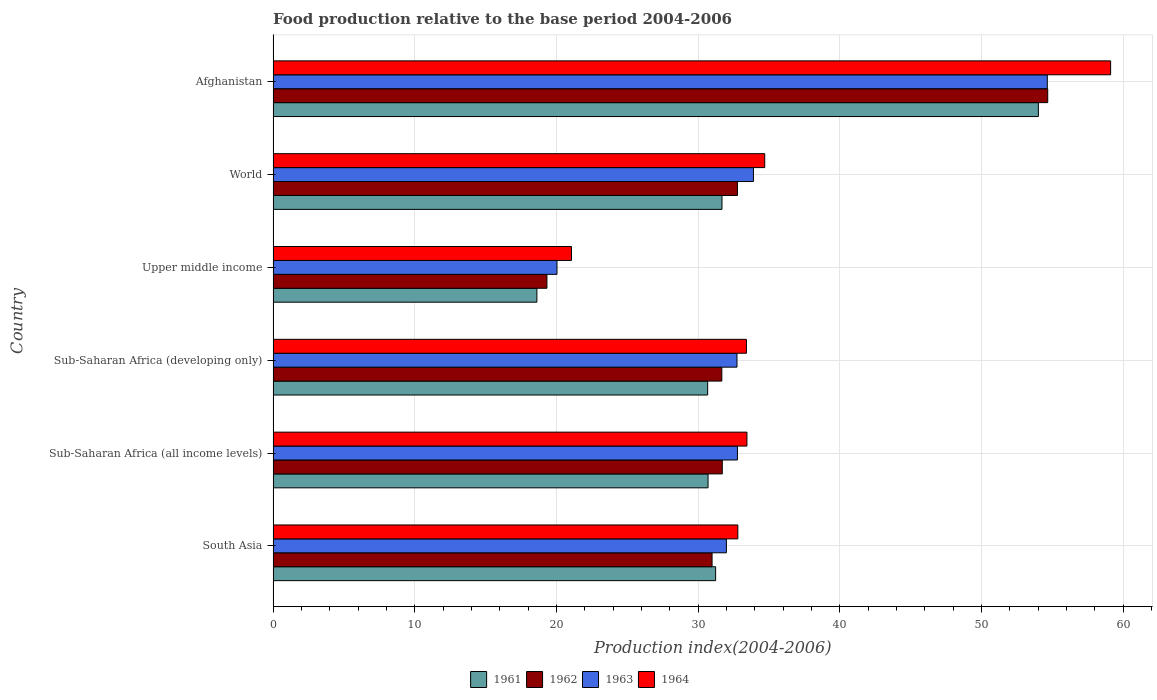How many bars are there on the 5th tick from the bottom?
Provide a short and direct response. 4. What is the label of the 1st group of bars from the top?
Provide a short and direct response. Afghanistan. In how many cases, is the number of bars for a given country not equal to the number of legend labels?
Your response must be concise. 0. What is the food production index in 1961 in Upper middle income?
Offer a terse response. 18.62. Across all countries, what is the maximum food production index in 1964?
Give a very brief answer. 59.12. Across all countries, what is the minimum food production index in 1961?
Provide a short and direct response. 18.62. In which country was the food production index in 1963 maximum?
Your answer should be very brief. Afghanistan. In which country was the food production index in 1961 minimum?
Make the answer very short. Upper middle income. What is the total food production index in 1964 in the graph?
Give a very brief answer. 214.55. What is the difference between the food production index in 1964 in Afghanistan and that in Sub-Saharan Africa (all income levels)?
Your response must be concise. 25.67. What is the difference between the food production index in 1962 in Sub-Saharan Africa (developing only) and the food production index in 1963 in Afghanistan?
Your answer should be compact. -22.97. What is the average food production index in 1964 per country?
Ensure brevity in your answer.  35.76. What is the difference between the food production index in 1963 and food production index in 1962 in Upper middle income?
Your answer should be compact. 0.71. What is the ratio of the food production index in 1963 in South Asia to that in Sub-Saharan Africa (all income levels)?
Your answer should be very brief. 0.98. Is the food production index in 1961 in Afghanistan less than that in Upper middle income?
Your answer should be very brief. No. What is the difference between the highest and the second highest food production index in 1963?
Provide a short and direct response. 20.74. What is the difference between the highest and the lowest food production index in 1962?
Keep it short and to the point. 35.35. Is it the case that in every country, the sum of the food production index in 1962 and food production index in 1961 is greater than the sum of food production index in 1964 and food production index in 1963?
Make the answer very short. No. What does the 1st bar from the top in World represents?
Make the answer very short. 1964. Is it the case that in every country, the sum of the food production index in 1963 and food production index in 1964 is greater than the food production index in 1961?
Offer a terse response. Yes. Are all the bars in the graph horizontal?
Your response must be concise. Yes. How many countries are there in the graph?
Ensure brevity in your answer.  6. What is the difference between two consecutive major ticks on the X-axis?
Ensure brevity in your answer.  10. Are the values on the major ticks of X-axis written in scientific E-notation?
Your response must be concise. No. Does the graph contain any zero values?
Ensure brevity in your answer.  No. Does the graph contain grids?
Ensure brevity in your answer.  Yes. Where does the legend appear in the graph?
Provide a short and direct response. Bottom center. What is the title of the graph?
Offer a very short reply. Food production relative to the base period 2004-2006. What is the label or title of the X-axis?
Make the answer very short. Production index(2004-2006). What is the Production index(2004-2006) in 1961 in South Asia?
Provide a succinct answer. 31.24. What is the Production index(2004-2006) of 1962 in South Asia?
Give a very brief answer. 30.99. What is the Production index(2004-2006) of 1963 in South Asia?
Ensure brevity in your answer.  32. What is the Production index(2004-2006) in 1964 in South Asia?
Give a very brief answer. 32.8. What is the Production index(2004-2006) in 1961 in Sub-Saharan Africa (all income levels)?
Offer a very short reply. 30.7. What is the Production index(2004-2006) in 1962 in Sub-Saharan Africa (all income levels)?
Make the answer very short. 31.71. What is the Production index(2004-2006) in 1963 in Sub-Saharan Africa (all income levels)?
Provide a succinct answer. 32.78. What is the Production index(2004-2006) of 1964 in Sub-Saharan Africa (all income levels)?
Keep it short and to the point. 33.45. What is the Production index(2004-2006) in 1961 in Sub-Saharan Africa (developing only)?
Provide a succinct answer. 30.68. What is the Production index(2004-2006) of 1962 in Sub-Saharan Africa (developing only)?
Ensure brevity in your answer.  31.68. What is the Production index(2004-2006) of 1963 in Sub-Saharan Africa (developing only)?
Provide a succinct answer. 32.75. What is the Production index(2004-2006) of 1964 in Sub-Saharan Africa (developing only)?
Keep it short and to the point. 33.41. What is the Production index(2004-2006) in 1961 in Upper middle income?
Offer a very short reply. 18.62. What is the Production index(2004-2006) in 1962 in Upper middle income?
Provide a short and direct response. 19.33. What is the Production index(2004-2006) of 1963 in Upper middle income?
Your response must be concise. 20.04. What is the Production index(2004-2006) of 1964 in Upper middle income?
Ensure brevity in your answer.  21.06. What is the Production index(2004-2006) in 1961 in World?
Your response must be concise. 31.69. What is the Production index(2004-2006) in 1962 in World?
Offer a terse response. 32.78. What is the Production index(2004-2006) of 1963 in World?
Provide a short and direct response. 33.91. What is the Production index(2004-2006) in 1964 in World?
Your answer should be very brief. 34.7. What is the Production index(2004-2006) in 1961 in Afghanistan?
Offer a very short reply. 54.02. What is the Production index(2004-2006) in 1962 in Afghanistan?
Make the answer very short. 54.68. What is the Production index(2004-2006) of 1963 in Afghanistan?
Ensure brevity in your answer.  54.65. What is the Production index(2004-2006) of 1964 in Afghanistan?
Give a very brief answer. 59.12. Across all countries, what is the maximum Production index(2004-2006) of 1961?
Your answer should be compact. 54.02. Across all countries, what is the maximum Production index(2004-2006) in 1962?
Your response must be concise. 54.68. Across all countries, what is the maximum Production index(2004-2006) in 1963?
Ensure brevity in your answer.  54.65. Across all countries, what is the maximum Production index(2004-2006) of 1964?
Give a very brief answer. 59.12. Across all countries, what is the minimum Production index(2004-2006) in 1961?
Give a very brief answer. 18.62. Across all countries, what is the minimum Production index(2004-2006) of 1962?
Ensure brevity in your answer.  19.33. Across all countries, what is the minimum Production index(2004-2006) in 1963?
Give a very brief answer. 20.04. Across all countries, what is the minimum Production index(2004-2006) in 1964?
Offer a terse response. 21.06. What is the total Production index(2004-2006) in 1961 in the graph?
Ensure brevity in your answer.  196.94. What is the total Production index(2004-2006) in 1962 in the graph?
Your response must be concise. 201.15. What is the total Production index(2004-2006) in 1963 in the graph?
Provide a short and direct response. 206.11. What is the total Production index(2004-2006) in 1964 in the graph?
Provide a short and direct response. 214.55. What is the difference between the Production index(2004-2006) in 1961 in South Asia and that in Sub-Saharan Africa (all income levels)?
Offer a terse response. 0.54. What is the difference between the Production index(2004-2006) of 1962 in South Asia and that in Sub-Saharan Africa (all income levels)?
Your answer should be compact. -0.72. What is the difference between the Production index(2004-2006) in 1963 in South Asia and that in Sub-Saharan Africa (all income levels)?
Provide a succinct answer. -0.78. What is the difference between the Production index(2004-2006) of 1964 in South Asia and that in Sub-Saharan Africa (all income levels)?
Offer a very short reply. -0.64. What is the difference between the Production index(2004-2006) of 1961 in South Asia and that in Sub-Saharan Africa (developing only)?
Provide a succinct answer. 0.56. What is the difference between the Production index(2004-2006) of 1962 in South Asia and that in Sub-Saharan Africa (developing only)?
Your response must be concise. -0.69. What is the difference between the Production index(2004-2006) in 1963 in South Asia and that in Sub-Saharan Africa (developing only)?
Ensure brevity in your answer.  -0.75. What is the difference between the Production index(2004-2006) of 1964 in South Asia and that in Sub-Saharan Africa (developing only)?
Your response must be concise. -0.61. What is the difference between the Production index(2004-2006) of 1961 in South Asia and that in Upper middle income?
Make the answer very short. 12.62. What is the difference between the Production index(2004-2006) of 1962 in South Asia and that in Upper middle income?
Your answer should be compact. 11.66. What is the difference between the Production index(2004-2006) in 1963 in South Asia and that in Upper middle income?
Your answer should be very brief. 11.96. What is the difference between the Production index(2004-2006) in 1964 in South Asia and that in Upper middle income?
Offer a very short reply. 11.74. What is the difference between the Production index(2004-2006) in 1961 in South Asia and that in World?
Give a very brief answer. -0.45. What is the difference between the Production index(2004-2006) in 1962 in South Asia and that in World?
Make the answer very short. -1.79. What is the difference between the Production index(2004-2006) of 1963 in South Asia and that in World?
Keep it short and to the point. -1.91. What is the difference between the Production index(2004-2006) of 1964 in South Asia and that in World?
Your response must be concise. -1.9. What is the difference between the Production index(2004-2006) of 1961 in South Asia and that in Afghanistan?
Your response must be concise. -22.78. What is the difference between the Production index(2004-2006) in 1962 in South Asia and that in Afghanistan?
Your response must be concise. -23.69. What is the difference between the Production index(2004-2006) of 1963 in South Asia and that in Afghanistan?
Offer a very short reply. -22.65. What is the difference between the Production index(2004-2006) of 1964 in South Asia and that in Afghanistan?
Offer a very short reply. -26.32. What is the difference between the Production index(2004-2006) of 1961 in Sub-Saharan Africa (all income levels) and that in Sub-Saharan Africa (developing only)?
Your answer should be compact. 0.03. What is the difference between the Production index(2004-2006) of 1962 in Sub-Saharan Africa (all income levels) and that in Sub-Saharan Africa (developing only)?
Offer a terse response. 0.03. What is the difference between the Production index(2004-2006) of 1963 in Sub-Saharan Africa (all income levels) and that in Sub-Saharan Africa (developing only)?
Keep it short and to the point. 0.03. What is the difference between the Production index(2004-2006) of 1964 in Sub-Saharan Africa (all income levels) and that in Sub-Saharan Africa (developing only)?
Your response must be concise. 0.04. What is the difference between the Production index(2004-2006) of 1961 in Sub-Saharan Africa (all income levels) and that in Upper middle income?
Offer a very short reply. 12.08. What is the difference between the Production index(2004-2006) in 1962 in Sub-Saharan Africa (all income levels) and that in Upper middle income?
Provide a succinct answer. 12.38. What is the difference between the Production index(2004-2006) in 1963 in Sub-Saharan Africa (all income levels) and that in Upper middle income?
Your response must be concise. 12.74. What is the difference between the Production index(2004-2006) in 1964 in Sub-Saharan Africa (all income levels) and that in Upper middle income?
Your response must be concise. 12.38. What is the difference between the Production index(2004-2006) in 1961 in Sub-Saharan Africa (all income levels) and that in World?
Give a very brief answer. -0.98. What is the difference between the Production index(2004-2006) of 1962 in Sub-Saharan Africa (all income levels) and that in World?
Offer a very short reply. -1.07. What is the difference between the Production index(2004-2006) in 1963 in Sub-Saharan Africa (all income levels) and that in World?
Ensure brevity in your answer.  -1.13. What is the difference between the Production index(2004-2006) of 1964 in Sub-Saharan Africa (all income levels) and that in World?
Your answer should be compact. -1.26. What is the difference between the Production index(2004-2006) of 1961 in Sub-Saharan Africa (all income levels) and that in Afghanistan?
Offer a terse response. -23.32. What is the difference between the Production index(2004-2006) of 1962 in Sub-Saharan Africa (all income levels) and that in Afghanistan?
Offer a terse response. -22.97. What is the difference between the Production index(2004-2006) in 1963 in Sub-Saharan Africa (all income levels) and that in Afghanistan?
Ensure brevity in your answer.  -21.87. What is the difference between the Production index(2004-2006) in 1964 in Sub-Saharan Africa (all income levels) and that in Afghanistan?
Offer a very short reply. -25.67. What is the difference between the Production index(2004-2006) in 1961 in Sub-Saharan Africa (developing only) and that in Upper middle income?
Give a very brief answer. 12.06. What is the difference between the Production index(2004-2006) in 1962 in Sub-Saharan Africa (developing only) and that in Upper middle income?
Make the answer very short. 12.35. What is the difference between the Production index(2004-2006) in 1963 in Sub-Saharan Africa (developing only) and that in Upper middle income?
Keep it short and to the point. 12.71. What is the difference between the Production index(2004-2006) in 1964 in Sub-Saharan Africa (developing only) and that in Upper middle income?
Offer a very short reply. 12.35. What is the difference between the Production index(2004-2006) in 1961 in Sub-Saharan Africa (developing only) and that in World?
Your response must be concise. -1.01. What is the difference between the Production index(2004-2006) of 1962 in Sub-Saharan Africa (developing only) and that in World?
Your response must be concise. -1.1. What is the difference between the Production index(2004-2006) of 1963 in Sub-Saharan Africa (developing only) and that in World?
Ensure brevity in your answer.  -1.16. What is the difference between the Production index(2004-2006) of 1964 in Sub-Saharan Africa (developing only) and that in World?
Offer a terse response. -1.29. What is the difference between the Production index(2004-2006) of 1961 in Sub-Saharan Africa (developing only) and that in Afghanistan?
Offer a very short reply. -23.34. What is the difference between the Production index(2004-2006) in 1962 in Sub-Saharan Africa (developing only) and that in Afghanistan?
Make the answer very short. -23. What is the difference between the Production index(2004-2006) of 1963 in Sub-Saharan Africa (developing only) and that in Afghanistan?
Make the answer very short. -21.91. What is the difference between the Production index(2004-2006) in 1964 in Sub-Saharan Africa (developing only) and that in Afghanistan?
Provide a succinct answer. -25.71. What is the difference between the Production index(2004-2006) in 1961 in Upper middle income and that in World?
Offer a very short reply. -13.07. What is the difference between the Production index(2004-2006) in 1962 in Upper middle income and that in World?
Provide a succinct answer. -13.45. What is the difference between the Production index(2004-2006) in 1963 in Upper middle income and that in World?
Offer a terse response. -13.87. What is the difference between the Production index(2004-2006) in 1964 in Upper middle income and that in World?
Your answer should be compact. -13.64. What is the difference between the Production index(2004-2006) in 1961 in Upper middle income and that in Afghanistan?
Offer a very short reply. -35.4. What is the difference between the Production index(2004-2006) in 1962 in Upper middle income and that in Afghanistan?
Offer a terse response. -35.35. What is the difference between the Production index(2004-2006) of 1963 in Upper middle income and that in Afghanistan?
Provide a short and direct response. -34.61. What is the difference between the Production index(2004-2006) in 1964 in Upper middle income and that in Afghanistan?
Keep it short and to the point. -38.06. What is the difference between the Production index(2004-2006) of 1961 in World and that in Afghanistan?
Offer a very short reply. -22.33. What is the difference between the Production index(2004-2006) in 1962 in World and that in Afghanistan?
Give a very brief answer. -21.9. What is the difference between the Production index(2004-2006) of 1963 in World and that in Afghanistan?
Offer a very short reply. -20.74. What is the difference between the Production index(2004-2006) in 1964 in World and that in Afghanistan?
Provide a short and direct response. -24.42. What is the difference between the Production index(2004-2006) in 1961 in South Asia and the Production index(2004-2006) in 1962 in Sub-Saharan Africa (all income levels)?
Offer a terse response. -0.47. What is the difference between the Production index(2004-2006) in 1961 in South Asia and the Production index(2004-2006) in 1963 in Sub-Saharan Africa (all income levels)?
Your answer should be compact. -1.54. What is the difference between the Production index(2004-2006) of 1961 in South Asia and the Production index(2004-2006) of 1964 in Sub-Saharan Africa (all income levels)?
Make the answer very short. -2.21. What is the difference between the Production index(2004-2006) in 1962 in South Asia and the Production index(2004-2006) in 1963 in Sub-Saharan Africa (all income levels)?
Provide a short and direct response. -1.79. What is the difference between the Production index(2004-2006) in 1962 in South Asia and the Production index(2004-2006) in 1964 in Sub-Saharan Africa (all income levels)?
Keep it short and to the point. -2.46. What is the difference between the Production index(2004-2006) of 1963 in South Asia and the Production index(2004-2006) of 1964 in Sub-Saharan Africa (all income levels)?
Give a very brief answer. -1.45. What is the difference between the Production index(2004-2006) of 1961 in South Asia and the Production index(2004-2006) of 1962 in Sub-Saharan Africa (developing only)?
Provide a short and direct response. -0.44. What is the difference between the Production index(2004-2006) of 1961 in South Asia and the Production index(2004-2006) of 1963 in Sub-Saharan Africa (developing only)?
Make the answer very short. -1.51. What is the difference between the Production index(2004-2006) of 1961 in South Asia and the Production index(2004-2006) of 1964 in Sub-Saharan Africa (developing only)?
Provide a succinct answer. -2.17. What is the difference between the Production index(2004-2006) of 1962 in South Asia and the Production index(2004-2006) of 1963 in Sub-Saharan Africa (developing only)?
Offer a very short reply. -1.76. What is the difference between the Production index(2004-2006) in 1962 in South Asia and the Production index(2004-2006) in 1964 in Sub-Saharan Africa (developing only)?
Make the answer very short. -2.43. What is the difference between the Production index(2004-2006) in 1963 in South Asia and the Production index(2004-2006) in 1964 in Sub-Saharan Africa (developing only)?
Provide a succinct answer. -1.42. What is the difference between the Production index(2004-2006) in 1961 in South Asia and the Production index(2004-2006) in 1962 in Upper middle income?
Offer a very short reply. 11.91. What is the difference between the Production index(2004-2006) of 1961 in South Asia and the Production index(2004-2006) of 1963 in Upper middle income?
Make the answer very short. 11.2. What is the difference between the Production index(2004-2006) in 1961 in South Asia and the Production index(2004-2006) in 1964 in Upper middle income?
Offer a terse response. 10.18. What is the difference between the Production index(2004-2006) of 1962 in South Asia and the Production index(2004-2006) of 1963 in Upper middle income?
Your answer should be compact. 10.95. What is the difference between the Production index(2004-2006) in 1962 in South Asia and the Production index(2004-2006) in 1964 in Upper middle income?
Your response must be concise. 9.92. What is the difference between the Production index(2004-2006) of 1963 in South Asia and the Production index(2004-2006) of 1964 in Upper middle income?
Offer a terse response. 10.93. What is the difference between the Production index(2004-2006) in 1961 in South Asia and the Production index(2004-2006) in 1962 in World?
Keep it short and to the point. -1.54. What is the difference between the Production index(2004-2006) in 1961 in South Asia and the Production index(2004-2006) in 1963 in World?
Provide a short and direct response. -2.67. What is the difference between the Production index(2004-2006) in 1961 in South Asia and the Production index(2004-2006) in 1964 in World?
Your answer should be compact. -3.47. What is the difference between the Production index(2004-2006) in 1962 in South Asia and the Production index(2004-2006) in 1963 in World?
Provide a short and direct response. -2.92. What is the difference between the Production index(2004-2006) in 1962 in South Asia and the Production index(2004-2006) in 1964 in World?
Provide a short and direct response. -3.72. What is the difference between the Production index(2004-2006) of 1963 in South Asia and the Production index(2004-2006) of 1964 in World?
Make the answer very short. -2.71. What is the difference between the Production index(2004-2006) of 1961 in South Asia and the Production index(2004-2006) of 1962 in Afghanistan?
Make the answer very short. -23.44. What is the difference between the Production index(2004-2006) in 1961 in South Asia and the Production index(2004-2006) in 1963 in Afghanistan?
Your answer should be very brief. -23.41. What is the difference between the Production index(2004-2006) of 1961 in South Asia and the Production index(2004-2006) of 1964 in Afghanistan?
Keep it short and to the point. -27.88. What is the difference between the Production index(2004-2006) of 1962 in South Asia and the Production index(2004-2006) of 1963 in Afghanistan?
Provide a succinct answer. -23.66. What is the difference between the Production index(2004-2006) of 1962 in South Asia and the Production index(2004-2006) of 1964 in Afghanistan?
Keep it short and to the point. -28.13. What is the difference between the Production index(2004-2006) in 1963 in South Asia and the Production index(2004-2006) in 1964 in Afghanistan?
Offer a terse response. -27.12. What is the difference between the Production index(2004-2006) of 1961 in Sub-Saharan Africa (all income levels) and the Production index(2004-2006) of 1962 in Sub-Saharan Africa (developing only)?
Your answer should be compact. -0.97. What is the difference between the Production index(2004-2006) of 1961 in Sub-Saharan Africa (all income levels) and the Production index(2004-2006) of 1963 in Sub-Saharan Africa (developing only)?
Keep it short and to the point. -2.04. What is the difference between the Production index(2004-2006) of 1961 in Sub-Saharan Africa (all income levels) and the Production index(2004-2006) of 1964 in Sub-Saharan Africa (developing only)?
Provide a succinct answer. -2.71. What is the difference between the Production index(2004-2006) of 1962 in Sub-Saharan Africa (all income levels) and the Production index(2004-2006) of 1963 in Sub-Saharan Africa (developing only)?
Your response must be concise. -1.04. What is the difference between the Production index(2004-2006) in 1962 in Sub-Saharan Africa (all income levels) and the Production index(2004-2006) in 1964 in Sub-Saharan Africa (developing only)?
Your answer should be very brief. -1.71. What is the difference between the Production index(2004-2006) of 1963 in Sub-Saharan Africa (all income levels) and the Production index(2004-2006) of 1964 in Sub-Saharan Africa (developing only)?
Your answer should be very brief. -0.63. What is the difference between the Production index(2004-2006) of 1961 in Sub-Saharan Africa (all income levels) and the Production index(2004-2006) of 1962 in Upper middle income?
Ensure brevity in your answer.  11.37. What is the difference between the Production index(2004-2006) of 1961 in Sub-Saharan Africa (all income levels) and the Production index(2004-2006) of 1963 in Upper middle income?
Keep it short and to the point. 10.66. What is the difference between the Production index(2004-2006) in 1961 in Sub-Saharan Africa (all income levels) and the Production index(2004-2006) in 1964 in Upper middle income?
Provide a short and direct response. 9.64. What is the difference between the Production index(2004-2006) in 1962 in Sub-Saharan Africa (all income levels) and the Production index(2004-2006) in 1963 in Upper middle income?
Provide a succinct answer. 11.67. What is the difference between the Production index(2004-2006) of 1962 in Sub-Saharan Africa (all income levels) and the Production index(2004-2006) of 1964 in Upper middle income?
Make the answer very short. 10.64. What is the difference between the Production index(2004-2006) in 1963 in Sub-Saharan Africa (all income levels) and the Production index(2004-2006) in 1964 in Upper middle income?
Your response must be concise. 11.71. What is the difference between the Production index(2004-2006) of 1961 in Sub-Saharan Africa (all income levels) and the Production index(2004-2006) of 1962 in World?
Keep it short and to the point. -2.08. What is the difference between the Production index(2004-2006) of 1961 in Sub-Saharan Africa (all income levels) and the Production index(2004-2006) of 1963 in World?
Your answer should be compact. -3.2. What is the difference between the Production index(2004-2006) of 1961 in Sub-Saharan Africa (all income levels) and the Production index(2004-2006) of 1964 in World?
Offer a very short reply. -4. What is the difference between the Production index(2004-2006) of 1962 in Sub-Saharan Africa (all income levels) and the Production index(2004-2006) of 1963 in World?
Make the answer very short. -2.2. What is the difference between the Production index(2004-2006) in 1962 in Sub-Saharan Africa (all income levels) and the Production index(2004-2006) in 1964 in World?
Offer a very short reply. -3. What is the difference between the Production index(2004-2006) of 1963 in Sub-Saharan Africa (all income levels) and the Production index(2004-2006) of 1964 in World?
Ensure brevity in your answer.  -1.93. What is the difference between the Production index(2004-2006) in 1961 in Sub-Saharan Africa (all income levels) and the Production index(2004-2006) in 1962 in Afghanistan?
Offer a very short reply. -23.98. What is the difference between the Production index(2004-2006) of 1961 in Sub-Saharan Africa (all income levels) and the Production index(2004-2006) of 1963 in Afghanistan?
Offer a very short reply. -23.95. What is the difference between the Production index(2004-2006) in 1961 in Sub-Saharan Africa (all income levels) and the Production index(2004-2006) in 1964 in Afghanistan?
Ensure brevity in your answer.  -28.42. What is the difference between the Production index(2004-2006) in 1962 in Sub-Saharan Africa (all income levels) and the Production index(2004-2006) in 1963 in Afghanistan?
Give a very brief answer. -22.94. What is the difference between the Production index(2004-2006) in 1962 in Sub-Saharan Africa (all income levels) and the Production index(2004-2006) in 1964 in Afghanistan?
Provide a succinct answer. -27.41. What is the difference between the Production index(2004-2006) of 1963 in Sub-Saharan Africa (all income levels) and the Production index(2004-2006) of 1964 in Afghanistan?
Make the answer very short. -26.34. What is the difference between the Production index(2004-2006) of 1961 in Sub-Saharan Africa (developing only) and the Production index(2004-2006) of 1962 in Upper middle income?
Provide a short and direct response. 11.35. What is the difference between the Production index(2004-2006) in 1961 in Sub-Saharan Africa (developing only) and the Production index(2004-2006) in 1963 in Upper middle income?
Ensure brevity in your answer.  10.64. What is the difference between the Production index(2004-2006) of 1961 in Sub-Saharan Africa (developing only) and the Production index(2004-2006) of 1964 in Upper middle income?
Offer a very short reply. 9.61. What is the difference between the Production index(2004-2006) in 1962 in Sub-Saharan Africa (developing only) and the Production index(2004-2006) in 1963 in Upper middle income?
Your answer should be compact. 11.64. What is the difference between the Production index(2004-2006) of 1962 in Sub-Saharan Africa (developing only) and the Production index(2004-2006) of 1964 in Upper middle income?
Give a very brief answer. 10.61. What is the difference between the Production index(2004-2006) in 1963 in Sub-Saharan Africa (developing only) and the Production index(2004-2006) in 1964 in Upper middle income?
Offer a terse response. 11.68. What is the difference between the Production index(2004-2006) of 1961 in Sub-Saharan Africa (developing only) and the Production index(2004-2006) of 1962 in World?
Make the answer very short. -2.1. What is the difference between the Production index(2004-2006) in 1961 in Sub-Saharan Africa (developing only) and the Production index(2004-2006) in 1963 in World?
Your response must be concise. -3.23. What is the difference between the Production index(2004-2006) of 1961 in Sub-Saharan Africa (developing only) and the Production index(2004-2006) of 1964 in World?
Ensure brevity in your answer.  -4.03. What is the difference between the Production index(2004-2006) in 1962 in Sub-Saharan Africa (developing only) and the Production index(2004-2006) in 1963 in World?
Your answer should be very brief. -2.23. What is the difference between the Production index(2004-2006) of 1962 in Sub-Saharan Africa (developing only) and the Production index(2004-2006) of 1964 in World?
Provide a succinct answer. -3.03. What is the difference between the Production index(2004-2006) of 1963 in Sub-Saharan Africa (developing only) and the Production index(2004-2006) of 1964 in World?
Ensure brevity in your answer.  -1.96. What is the difference between the Production index(2004-2006) of 1961 in Sub-Saharan Africa (developing only) and the Production index(2004-2006) of 1962 in Afghanistan?
Your answer should be compact. -24. What is the difference between the Production index(2004-2006) of 1961 in Sub-Saharan Africa (developing only) and the Production index(2004-2006) of 1963 in Afghanistan?
Give a very brief answer. -23.97. What is the difference between the Production index(2004-2006) in 1961 in Sub-Saharan Africa (developing only) and the Production index(2004-2006) in 1964 in Afghanistan?
Offer a terse response. -28.44. What is the difference between the Production index(2004-2006) of 1962 in Sub-Saharan Africa (developing only) and the Production index(2004-2006) of 1963 in Afghanistan?
Offer a terse response. -22.97. What is the difference between the Production index(2004-2006) of 1962 in Sub-Saharan Africa (developing only) and the Production index(2004-2006) of 1964 in Afghanistan?
Provide a succinct answer. -27.44. What is the difference between the Production index(2004-2006) of 1963 in Sub-Saharan Africa (developing only) and the Production index(2004-2006) of 1964 in Afghanistan?
Provide a succinct answer. -26.38. What is the difference between the Production index(2004-2006) in 1961 in Upper middle income and the Production index(2004-2006) in 1962 in World?
Offer a terse response. -14.16. What is the difference between the Production index(2004-2006) in 1961 in Upper middle income and the Production index(2004-2006) in 1963 in World?
Make the answer very short. -15.29. What is the difference between the Production index(2004-2006) of 1961 in Upper middle income and the Production index(2004-2006) of 1964 in World?
Offer a very short reply. -16.08. What is the difference between the Production index(2004-2006) in 1962 in Upper middle income and the Production index(2004-2006) in 1963 in World?
Ensure brevity in your answer.  -14.58. What is the difference between the Production index(2004-2006) of 1962 in Upper middle income and the Production index(2004-2006) of 1964 in World?
Keep it short and to the point. -15.38. What is the difference between the Production index(2004-2006) in 1963 in Upper middle income and the Production index(2004-2006) in 1964 in World?
Provide a succinct answer. -14.67. What is the difference between the Production index(2004-2006) in 1961 in Upper middle income and the Production index(2004-2006) in 1962 in Afghanistan?
Your answer should be compact. -36.06. What is the difference between the Production index(2004-2006) of 1961 in Upper middle income and the Production index(2004-2006) of 1963 in Afghanistan?
Offer a very short reply. -36.03. What is the difference between the Production index(2004-2006) in 1961 in Upper middle income and the Production index(2004-2006) in 1964 in Afghanistan?
Ensure brevity in your answer.  -40.5. What is the difference between the Production index(2004-2006) of 1962 in Upper middle income and the Production index(2004-2006) of 1963 in Afghanistan?
Offer a very short reply. -35.32. What is the difference between the Production index(2004-2006) of 1962 in Upper middle income and the Production index(2004-2006) of 1964 in Afghanistan?
Your answer should be compact. -39.79. What is the difference between the Production index(2004-2006) in 1963 in Upper middle income and the Production index(2004-2006) in 1964 in Afghanistan?
Your answer should be very brief. -39.08. What is the difference between the Production index(2004-2006) of 1961 in World and the Production index(2004-2006) of 1962 in Afghanistan?
Give a very brief answer. -22.99. What is the difference between the Production index(2004-2006) of 1961 in World and the Production index(2004-2006) of 1963 in Afghanistan?
Give a very brief answer. -22.96. What is the difference between the Production index(2004-2006) in 1961 in World and the Production index(2004-2006) in 1964 in Afghanistan?
Your response must be concise. -27.43. What is the difference between the Production index(2004-2006) in 1962 in World and the Production index(2004-2006) in 1963 in Afghanistan?
Keep it short and to the point. -21.87. What is the difference between the Production index(2004-2006) in 1962 in World and the Production index(2004-2006) in 1964 in Afghanistan?
Offer a very short reply. -26.34. What is the difference between the Production index(2004-2006) in 1963 in World and the Production index(2004-2006) in 1964 in Afghanistan?
Your answer should be compact. -25.21. What is the average Production index(2004-2006) of 1961 per country?
Offer a very short reply. 32.82. What is the average Production index(2004-2006) in 1962 per country?
Ensure brevity in your answer.  33.53. What is the average Production index(2004-2006) of 1963 per country?
Your answer should be compact. 34.35. What is the average Production index(2004-2006) in 1964 per country?
Provide a succinct answer. 35.76. What is the difference between the Production index(2004-2006) of 1961 and Production index(2004-2006) of 1962 in South Asia?
Keep it short and to the point. 0.25. What is the difference between the Production index(2004-2006) in 1961 and Production index(2004-2006) in 1963 in South Asia?
Keep it short and to the point. -0.76. What is the difference between the Production index(2004-2006) in 1961 and Production index(2004-2006) in 1964 in South Asia?
Ensure brevity in your answer.  -1.57. What is the difference between the Production index(2004-2006) of 1962 and Production index(2004-2006) of 1963 in South Asia?
Keep it short and to the point. -1.01. What is the difference between the Production index(2004-2006) of 1962 and Production index(2004-2006) of 1964 in South Asia?
Make the answer very short. -1.82. What is the difference between the Production index(2004-2006) in 1963 and Production index(2004-2006) in 1964 in South Asia?
Your answer should be compact. -0.81. What is the difference between the Production index(2004-2006) in 1961 and Production index(2004-2006) in 1962 in Sub-Saharan Africa (all income levels)?
Keep it short and to the point. -1. What is the difference between the Production index(2004-2006) of 1961 and Production index(2004-2006) of 1963 in Sub-Saharan Africa (all income levels)?
Keep it short and to the point. -2.08. What is the difference between the Production index(2004-2006) in 1961 and Production index(2004-2006) in 1964 in Sub-Saharan Africa (all income levels)?
Provide a succinct answer. -2.74. What is the difference between the Production index(2004-2006) of 1962 and Production index(2004-2006) of 1963 in Sub-Saharan Africa (all income levels)?
Your answer should be compact. -1.07. What is the difference between the Production index(2004-2006) in 1962 and Production index(2004-2006) in 1964 in Sub-Saharan Africa (all income levels)?
Your answer should be very brief. -1.74. What is the difference between the Production index(2004-2006) in 1963 and Production index(2004-2006) in 1964 in Sub-Saharan Africa (all income levels)?
Provide a short and direct response. -0.67. What is the difference between the Production index(2004-2006) in 1961 and Production index(2004-2006) in 1962 in Sub-Saharan Africa (developing only)?
Your answer should be very brief. -1. What is the difference between the Production index(2004-2006) of 1961 and Production index(2004-2006) of 1963 in Sub-Saharan Africa (developing only)?
Keep it short and to the point. -2.07. What is the difference between the Production index(2004-2006) in 1961 and Production index(2004-2006) in 1964 in Sub-Saharan Africa (developing only)?
Keep it short and to the point. -2.74. What is the difference between the Production index(2004-2006) of 1962 and Production index(2004-2006) of 1963 in Sub-Saharan Africa (developing only)?
Your response must be concise. -1.07. What is the difference between the Production index(2004-2006) in 1962 and Production index(2004-2006) in 1964 in Sub-Saharan Africa (developing only)?
Keep it short and to the point. -1.74. What is the difference between the Production index(2004-2006) of 1963 and Production index(2004-2006) of 1964 in Sub-Saharan Africa (developing only)?
Your answer should be compact. -0.67. What is the difference between the Production index(2004-2006) in 1961 and Production index(2004-2006) in 1962 in Upper middle income?
Offer a very short reply. -0.71. What is the difference between the Production index(2004-2006) in 1961 and Production index(2004-2006) in 1963 in Upper middle income?
Ensure brevity in your answer.  -1.42. What is the difference between the Production index(2004-2006) in 1961 and Production index(2004-2006) in 1964 in Upper middle income?
Your answer should be compact. -2.44. What is the difference between the Production index(2004-2006) in 1962 and Production index(2004-2006) in 1963 in Upper middle income?
Provide a short and direct response. -0.71. What is the difference between the Production index(2004-2006) of 1962 and Production index(2004-2006) of 1964 in Upper middle income?
Provide a short and direct response. -1.73. What is the difference between the Production index(2004-2006) in 1963 and Production index(2004-2006) in 1964 in Upper middle income?
Provide a short and direct response. -1.02. What is the difference between the Production index(2004-2006) of 1961 and Production index(2004-2006) of 1962 in World?
Offer a very short reply. -1.09. What is the difference between the Production index(2004-2006) of 1961 and Production index(2004-2006) of 1963 in World?
Make the answer very short. -2.22. What is the difference between the Production index(2004-2006) of 1961 and Production index(2004-2006) of 1964 in World?
Keep it short and to the point. -3.02. What is the difference between the Production index(2004-2006) of 1962 and Production index(2004-2006) of 1963 in World?
Provide a short and direct response. -1.13. What is the difference between the Production index(2004-2006) of 1962 and Production index(2004-2006) of 1964 in World?
Make the answer very short. -1.92. What is the difference between the Production index(2004-2006) in 1963 and Production index(2004-2006) in 1964 in World?
Keep it short and to the point. -0.8. What is the difference between the Production index(2004-2006) in 1961 and Production index(2004-2006) in 1962 in Afghanistan?
Give a very brief answer. -0.66. What is the difference between the Production index(2004-2006) in 1961 and Production index(2004-2006) in 1963 in Afghanistan?
Your answer should be very brief. -0.63. What is the difference between the Production index(2004-2006) of 1961 and Production index(2004-2006) of 1964 in Afghanistan?
Your answer should be very brief. -5.1. What is the difference between the Production index(2004-2006) in 1962 and Production index(2004-2006) in 1963 in Afghanistan?
Offer a very short reply. 0.03. What is the difference between the Production index(2004-2006) in 1962 and Production index(2004-2006) in 1964 in Afghanistan?
Your response must be concise. -4.44. What is the difference between the Production index(2004-2006) in 1963 and Production index(2004-2006) in 1964 in Afghanistan?
Provide a short and direct response. -4.47. What is the ratio of the Production index(2004-2006) in 1961 in South Asia to that in Sub-Saharan Africa (all income levels)?
Give a very brief answer. 1.02. What is the ratio of the Production index(2004-2006) in 1962 in South Asia to that in Sub-Saharan Africa (all income levels)?
Offer a very short reply. 0.98. What is the ratio of the Production index(2004-2006) in 1963 in South Asia to that in Sub-Saharan Africa (all income levels)?
Your answer should be compact. 0.98. What is the ratio of the Production index(2004-2006) in 1964 in South Asia to that in Sub-Saharan Africa (all income levels)?
Ensure brevity in your answer.  0.98. What is the ratio of the Production index(2004-2006) of 1961 in South Asia to that in Sub-Saharan Africa (developing only)?
Offer a very short reply. 1.02. What is the ratio of the Production index(2004-2006) of 1962 in South Asia to that in Sub-Saharan Africa (developing only)?
Ensure brevity in your answer.  0.98. What is the ratio of the Production index(2004-2006) in 1963 in South Asia to that in Sub-Saharan Africa (developing only)?
Provide a succinct answer. 0.98. What is the ratio of the Production index(2004-2006) of 1964 in South Asia to that in Sub-Saharan Africa (developing only)?
Keep it short and to the point. 0.98. What is the ratio of the Production index(2004-2006) of 1961 in South Asia to that in Upper middle income?
Provide a short and direct response. 1.68. What is the ratio of the Production index(2004-2006) of 1962 in South Asia to that in Upper middle income?
Your response must be concise. 1.6. What is the ratio of the Production index(2004-2006) in 1963 in South Asia to that in Upper middle income?
Offer a very short reply. 1.6. What is the ratio of the Production index(2004-2006) of 1964 in South Asia to that in Upper middle income?
Ensure brevity in your answer.  1.56. What is the ratio of the Production index(2004-2006) in 1961 in South Asia to that in World?
Provide a short and direct response. 0.99. What is the ratio of the Production index(2004-2006) of 1962 in South Asia to that in World?
Your answer should be compact. 0.95. What is the ratio of the Production index(2004-2006) in 1963 in South Asia to that in World?
Give a very brief answer. 0.94. What is the ratio of the Production index(2004-2006) in 1964 in South Asia to that in World?
Keep it short and to the point. 0.95. What is the ratio of the Production index(2004-2006) in 1961 in South Asia to that in Afghanistan?
Your answer should be compact. 0.58. What is the ratio of the Production index(2004-2006) of 1962 in South Asia to that in Afghanistan?
Keep it short and to the point. 0.57. What is the ratio of the Production index(2004-2006) of 1963 in South Asia to that in Afghanistan?
Provide a succinct answer. 0.59. What is the ratio of the Production index(2004-2006) of 1964 in South Asia to that in Afghanistan?
Give a very brief answer. 0.55. What is the ratio of the Production index(2004-2006) in 1962 in Sub-Saharan Africa (all income levels) to that in Sub-Saharan Africa (developing only)?
Your answer should be very brief. 1. What is the ratio of the Production index(2004-2006) of 1963 in Sub-Saharan Africa (all income levels) to that in Sub-Saharan Africa (developing only)?
Offer a terse response. 1. What is the ratio of the Production index(2004-2006) of 1961 in Sub-Saharan Africa (all income levels) to that in Upper middle income?
Keep it short and to the point. 1.65. What is the ratio of the Production index(2004-2006) of 1962 in Sub-Saharan Africa (all income levels) to that in Upper middle income?
Your response must be concise. 1.64. What is the ratio of the Production index(2004-2006) of 1963 in Sub-Saharan Africa (all income levels) to that in Upper middle income?
Make the answer very short. 1.64. What is the ratio of the Production index(2004-2006) of 1964 in Sub-Saharan Africa (all income levels) to that in Upper middle income?
Your answer should be very brief. 1.59. What is the ratio of the Production index(2004-2006) of 1961 in Sub-Saharan Africa (all income levels) to that in World?
Provide a short and direct response. 0.97. What is the ratio of the Production index(2004-2006) in 1962 in Sub-Saharan Africa (all income levels) to that in World?
Give a very brief answer. 0.97. What is the ratio of the Production index(2004-2006) in 1963 in Sub-Saharan Africa (all income levels) to that in World?
Keep it short and to the point. 0.97. What is the ratio of the Production index(2004-2006) of 1964 in Sub-Saharan Africa (all income levels) to that in World?
Provide a short and direct response. 0.96. What is the ratio of the Production index(2004-2006) of 1961 in Sub-Saharan Africa (all income levels) to that in Afghanistan?
Make the answer very short. 0.57. What is the ratio of the Production index(2004-2006) in 1962 in Sub-Saharan Africa (all income levels) to that in Afghanistan?
Give a very brief answer. 0.58. What is the ratio of the Production index(2004-2006) of 1963 in Sub-Saharan Africa (all income levels) to that in Afghanistan?
Your answer should be very brief. 0.6. What is the ratio of the Production index(2004-2006) in 1964 in Sub-Saharan Africa (all income levels) to that in Afghanistan?
Your response must be concise. 0.57. What is the ratio of the Production index(2004-2006) of 1961 in Sub-Saharan Africa (developing only) to that in Upper middle income?
Your answer should be very brief. 1.65. What is the ratio of the Production index(2004-2006) in 1962 in Sub-Saharan Africa (developing only) to that in Upper middle income?
Offer a very short reply. 1.64. What is the ratio of the Production index(2004-2006) of 1963 in Sub-Saharan Africa (developing only) to that in Upper middle income?
Provide a short and direct response. 1.63. What is the ratio of the Production index(2004-2006) in 1964 in Sub-Saharan Africa (developing only) to that in Upper middle income?
Your response must be concise. 1.59. What is the ratio of the Production index(2004-2006) in 1961 in Sub-Saharan Africa (developing only) to that in World?
Provide a succinct answer. 0.97. What is the ratio of the Production index(2004-2006) of 1962 in Sub-Saharan Africa (developing only) to that in World?
Offer a terse response. 0.97. What is the ratio of the Production index(2004-2006) of 1963 in Sub-Saharan Africa (developing only) to that in World?
Your answer should be very brief. 0.97. What is the ratio of the Production index(2004-2006) of 1964 in Sub-Saharan Africa (developing only) to that in World?
Give a very brief answer. 0.96. What is the ratio of the Production index(2004-2006) in 1961 in Sub-Saharan Africa (developing only) to that in Afghanistan?
Your answer should be very brief. 0.57. What is the ratio of the Production index(2004-2006) in 1962 in Sub-Saharan Africa (developing only) to that in Afghanistan?
Provide a succinct answer. 0.58. What is the ratio of the Production index(2004-2006) of 1963 in Sub-Saharan Africa (developing only) to that in Afghanistan?
Your answer should be very brief. 0.6. What is the ratio of the Production index(2004-2006) of 1964 in Sub-Saharan Africa (developing only) to that in Afghanistan?
Offer a very short reply. 0.57. What is the ratio of the Production index(2004-2006) of 1961 in Upper middle income to that in World?
Ensure brevity in your answer.  0.59. What is the ratio of the Production index(2004-2006) in 1962 in Upper middle income to that in World?
Provide a short and direct response. 0.59. What is the ratio of the Production index(2004-2006) in 1963 in Upper middle income to that in World?
Make the answer very short. 0.59. What is the ratio of the Production index(2004-2006) in 1964 in Upper middle income to that in World?
Offer a terse response. 0.61. What is the ratio of the Production index(2004-2006) in 1961 in Upper middle income to that in Afghanistan?
Ensure brevity in your answer.  0.34. What is the ratio of the Production index(2004-2006) of 1962 in Upper middle income to that in Afghanistan?
Keep it short and to the point. 0.35. What is the ratio of the Production index(2004-2006) of 1963 in Upper middle income to that in Afghanistan?
Provide a succinct answer. 0.37. What is the ratio of the Production index(2004-2006) in 1964 in Upper middle income to that in Afghanistan?
Provide a succinct answer. 0.36. What is the ratio of the Production index(2004-2006) of 1961 in World to that in Afghanistan?
Your answer should be very brief. 0.59. What is the ratio of the Production index(2004-2006) in 1962 in World to that in Afghanistan?
Ensure brevity in your answer.  0.6. What is the ratio of the Production index(2004-2006) in 1963 in World to that in Afghanistan?
Give a very brief answer. 0.62. What is the ratio of the Production index(2004-2006) in 1964 in World to that in Afghanistan?
Provide a succinct answer. 0.59. What is the difference between the highest and the second highest Production index(2004-2006) of 1961?
Offer a very short reply. 22.33. What is the difference between the highest and the second highest Production index(2004-2006) in 1962?
Provide a short and direct response. 21.9. What is the difference between the highest and the second highest Production index(2004-2006) in 1963?
Ensure brevity in your answer.  20.74. What is the difference between the highest and the second highest Production index(2004-2006) of 1964?
Your answer should be very brief. 24.42. What is the difference between the highest and the lowest Production index(2004-2006) in 1961?
Give a very brief answer. 35.4. What is the difference between the highest and the lowest Production index(2004-2006) of 1962?
Your response must be concise. 35.35. What is the difference between the highest and the lowest Production index(2004-2006) of 1963?
Offer a terse response. 34.61. What is the difference between the highest and the lowest Production index(2004-2006) of 1964?
Your response must be concise. 38.06. 